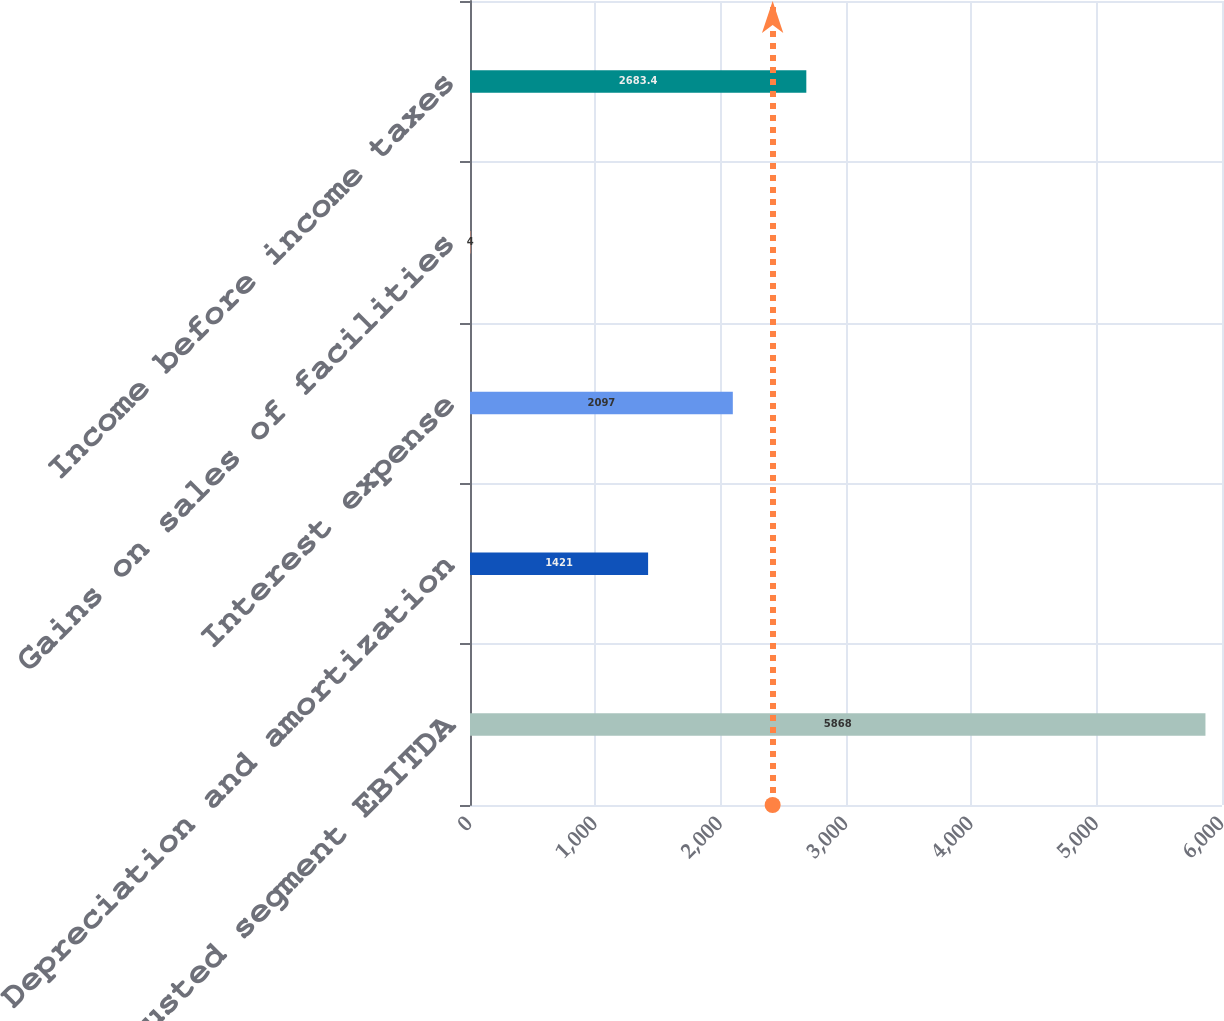Convert chart to OTSL. <chart><loc_0><loc_0><loc_500><loc_500><bar_chart><fcel>Adjusted segment EBITDA<fcel>Depreciation and amortization<fcel>Interest expense<fcel>Gains on sales of facilities<fcel>Income before income taxes<nl><fcel>5868<fcel>1421<fcel>2097<fcel>4<fcel>2683.4<nl></chart> 